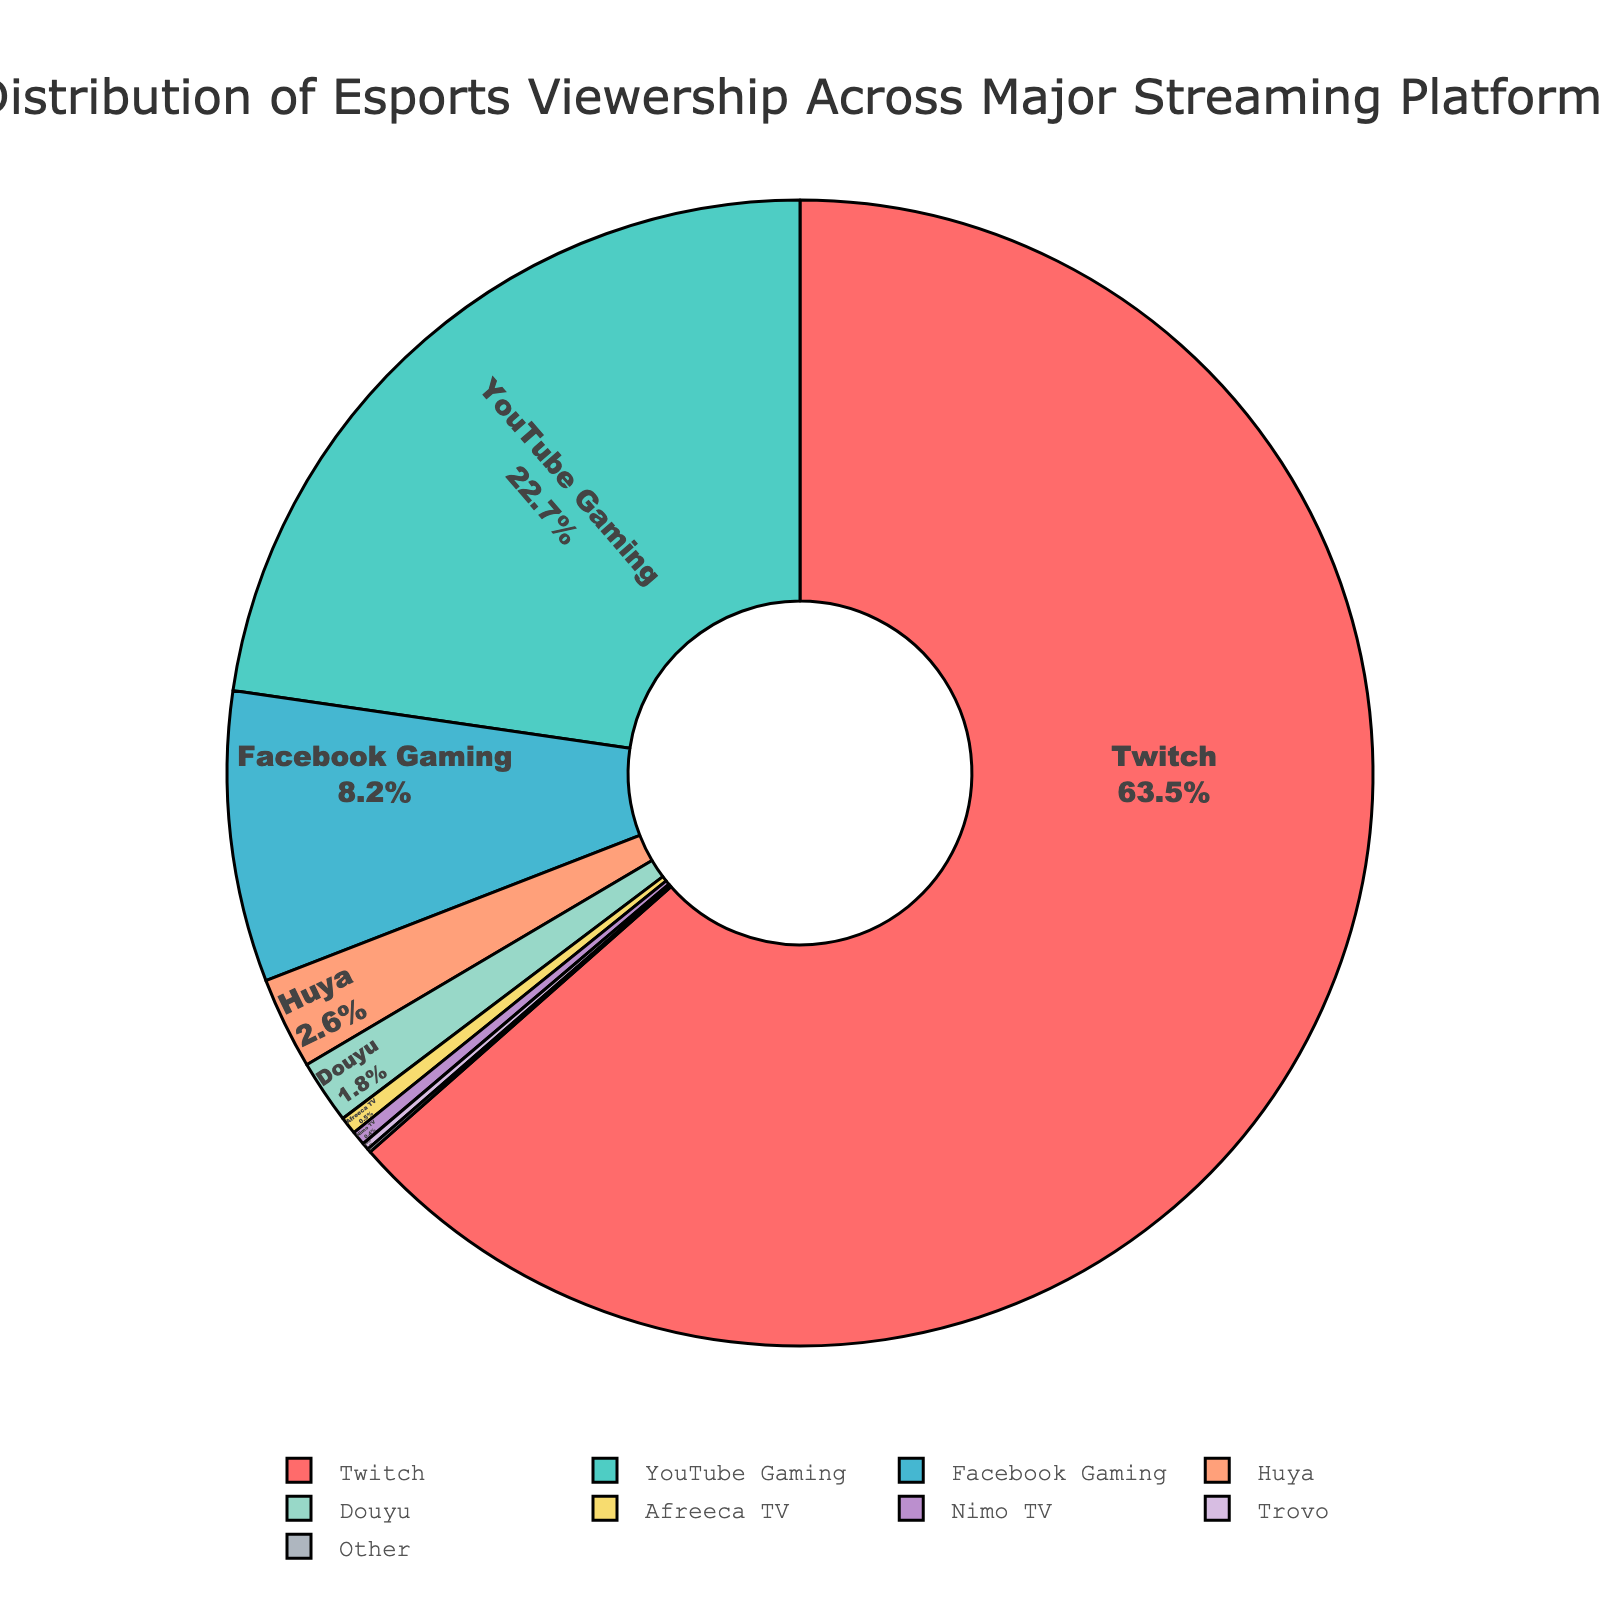Which platform has the highest percentage of esports viewership? The platform with the highest percentage is immediately visible as the largest slice in the pie chart. By observation, Twitch occupies the largest segment.
Answer: Twitch What percentage of esports viewership is shared by YouTube Gaming and Facebook Gaming combined? YouTube Gaming has 22.7% and Facebook Gaming has 8.2%. Summing these values, 22.7 + 8.2 = 30.9%.
Answer: 30.9% What is the difference in viewership percentage between Twitch and Douyu? Twitch has 63.5% and Douyu has 1.8%. Subtracting Douyu's percentage from Twitch's gives 63.5 - 1.8 = 61.7%.
Answer: 61.7% Among the platforms listed, which occupies the smallest slice of the pie chart? By looking for the smallest slice visually, Nimo TV with 0.4%, Trovo with 0.2%, and Other with 0.1%, Other is the smallest.
Answer: Other How many platforms have a viewership percentage less than 5%? By counting the segments with percentages less than 5%, we observe that Huya (2.6%), Douyu (1.8%), Afreeca TV (0.5%), Nimo TV (0.4%), Trovo (0.2%), and Other (0.1%) all fit this criterion. Hence, six platforms.
Answer: 6 How much more percentage does Twitch have compared to all the other platforms combined (excluding Twitch's percentage)? Adding up all other platforms’ percentages: 22.7 (YouTube Gaming) + 8.2 (Facebook Gaming) + 2.6 (Huya) + 1.8 (Douyu) + 0.5 (Afreeca TV) + 0.4 (Nimo TV) + 0.2 (Trovo) + 0.1 (Other) equals 36.5%. Twitch’s percentage is 63.5%. The difference is 63.5 - 36.5 = 27%.
Answer: 27% What proportion of viewership is from platforms other than Twitch, YouTube Gaming, and Facebook Gaming? Summing up percentages of Huya (2.6%), Douyu (1.8%), Afreeca TV (0.5%), Nimo TV (0.4%), Trovo (0.2%), and Other (0.1%): 2.6 + 1.8 + 0.5 + 0.4 + 0.2 + 0.1 = 5.6%.
Answer: 5.6% If the total viewership was 10 million, how many viewers would correspond to the slice represented by Huya? Huya represents 2.6% of the total viewership. Multiplying 10 million by 2.6% (or 0.026): 10,000,000 * 0.026 = 260,000 viewers.
Answer: 260,000 viewers 